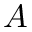<formula> <loc_0><loc_0><loc_500><loc_500>A</formula> 